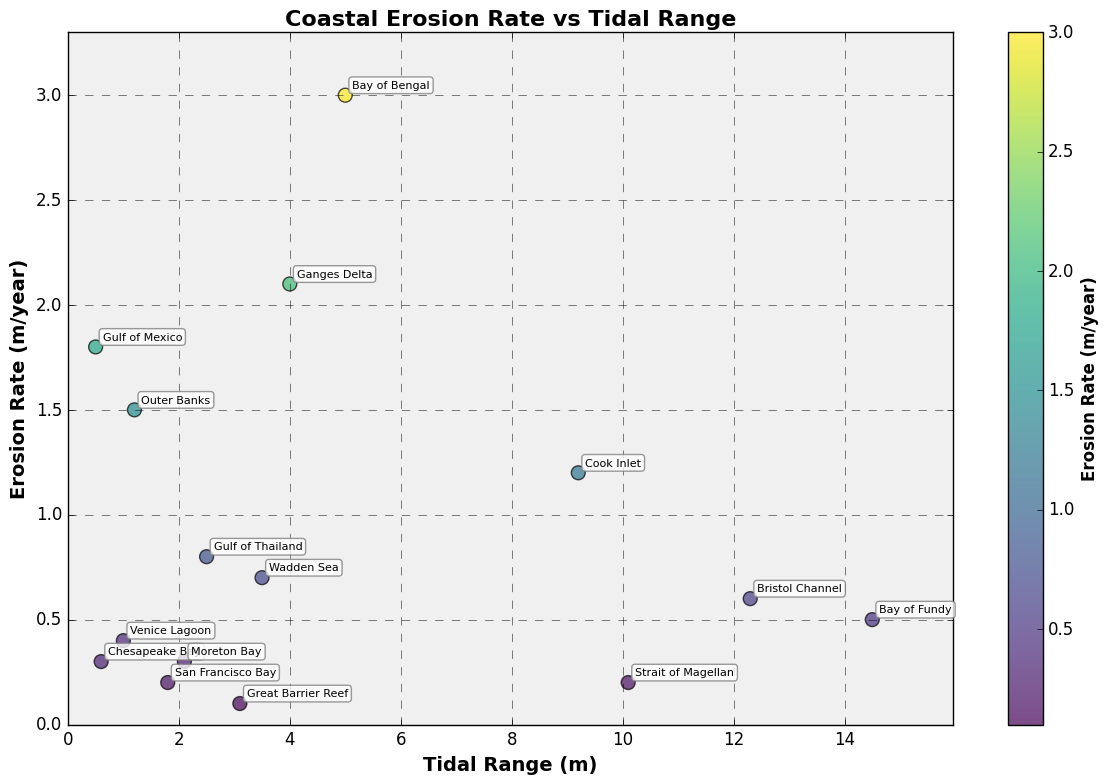what is the title of the plot? The title of the plot is located at the top center and is usually formatted in a larger, bold font compared to other text elements.
Answer: Coastal Erosion Rate vs Tidal Range how many locations are plotted in the figure? Each data point on the scatter plot represents a different location. By counting the number of distinct points, we can determine the total number of locations.
Answer: 15 which location has the highest erosion rate? This can be determined by looking at the y-axis (Erosion Rate) and identifying the highest data point along that axis. The annotation next to the point will provide the location name.
Answer: Bay of Bengal what is the tidal range for Cook Inlet? To find the tidal range for Cook Inlet, we locate the point labeled "Cook Inlet" and read the corresponding value on the x-axis (Tidal Range).
Answer: 9.2 meters compare the erosion rates of Chesapeake Bay and Outer Banks. Which one is higher? Find the points labeled "Chesapeake Bay" and "Outer Banks" and compare their y-values (Erosion Rate).
Answer: Outer Banks do locations with higher tidal ranges tend to have higher erosion rates? This question requires an observation of the general trend in the scatter plot, looking to see if higher x-values (Tidal Range) correlate with higher y-values (Erosion Rate).
Answer: No clear trend what is the average erosion rate of the locations with tidal ranges above 5 meters? Identify the points with x-values (Tidal Range) greater than 5 meters, sum their y-values (Erosion Rate), and divide by the number of such points.
Answer: (0.5 + 1.2 + 0.6 + 3.0 + 0.2) / 5 = 5.5 / 5 = 1.1 meters/year which location has both a tidal range greater than 10 meters and an erosion rate below 1 meter/year? Locate the data points with x-values over 10 meters and then check which of these has a y-value below 1 meter/year. Identify the location next to that point.
Answer: Bristol Channel what are the erosion rates of the locations with the highest and lowest tidal ranges? Identify the locations with the maximum and minimum x-values (Tidal Range) and note their corresponding y-values (Erosion Rate).
Answer: Bay of Fundy: 0.5 meters/year, Gulf of Mexico: 1.8 meters/year between the Gulf of Thailand and the Ganges Delta, which has a higher tidal range and by how much? Compare the x-values (Tidal Range) for both locations and calculate the difference between them.
Answer: Ganges Delta is higher by 1.5 meters 